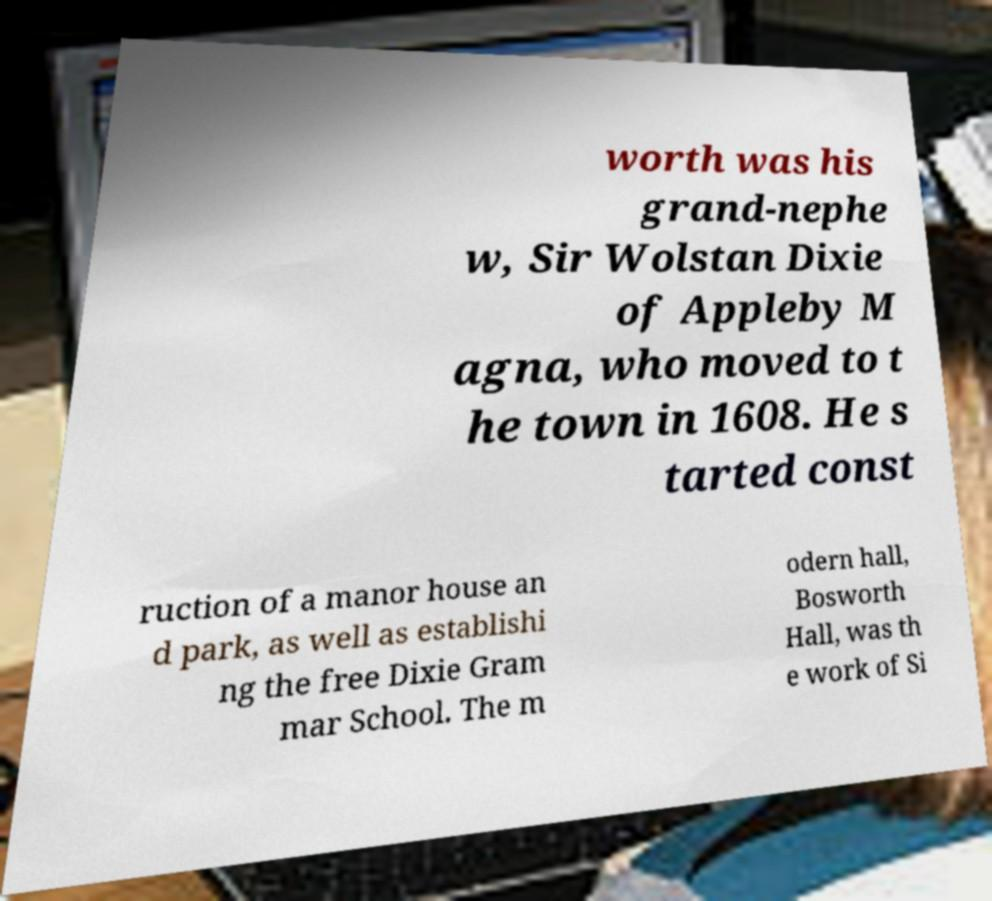Can you read and provide the text displayed in the image?This photo seems to have some interesting text. Can you extract and type it out for me? worth was his grand-nephe w, Sir Wolstan Dixie of Appleby M agna, who moved to t he town in 1608. He s tarted const ruction of a manor house an d park, as well as establishi ng the free Dixie Gram mar School. The m odern hall, Bosworth Hall, was th e work of Si 